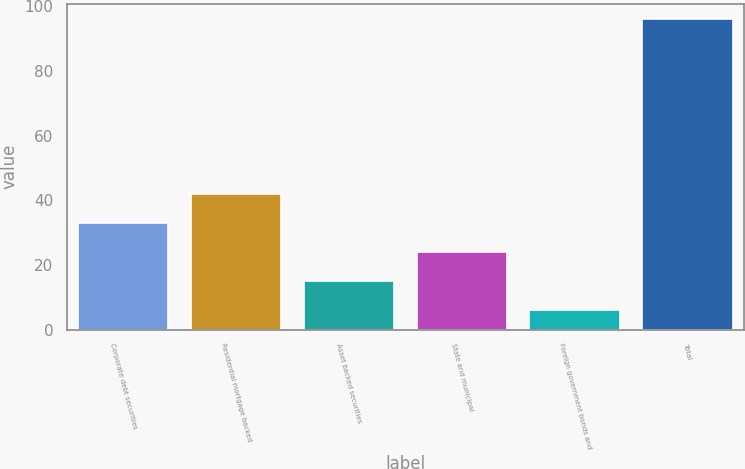<chart> <loc_0><loc_0><loc_500><loc_500><bar_chart><fcel>Corporate debt securities<fcel>Residential mortgage backed<fcel>Asset backed securities<fcel>State and municipal<fcel>Foreign government bonds and<fcel>Total<nl><fcel>33<fcel>42<fcel>15<fcel>24<fcel>6<fcel>96<nl></chart> 